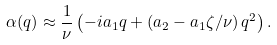Convert formula to latex. <formula><loc_0><loc_0><loc_500><loc_500>\alpha ( q ) \approx \frac { 1 } { \nu } \left ( - i a _ { 1 } q + \left ( a _ { 2 } - a _ { 1 } \zeta / \nu \right ) q ^ { 2 } \right ) .</formula> 